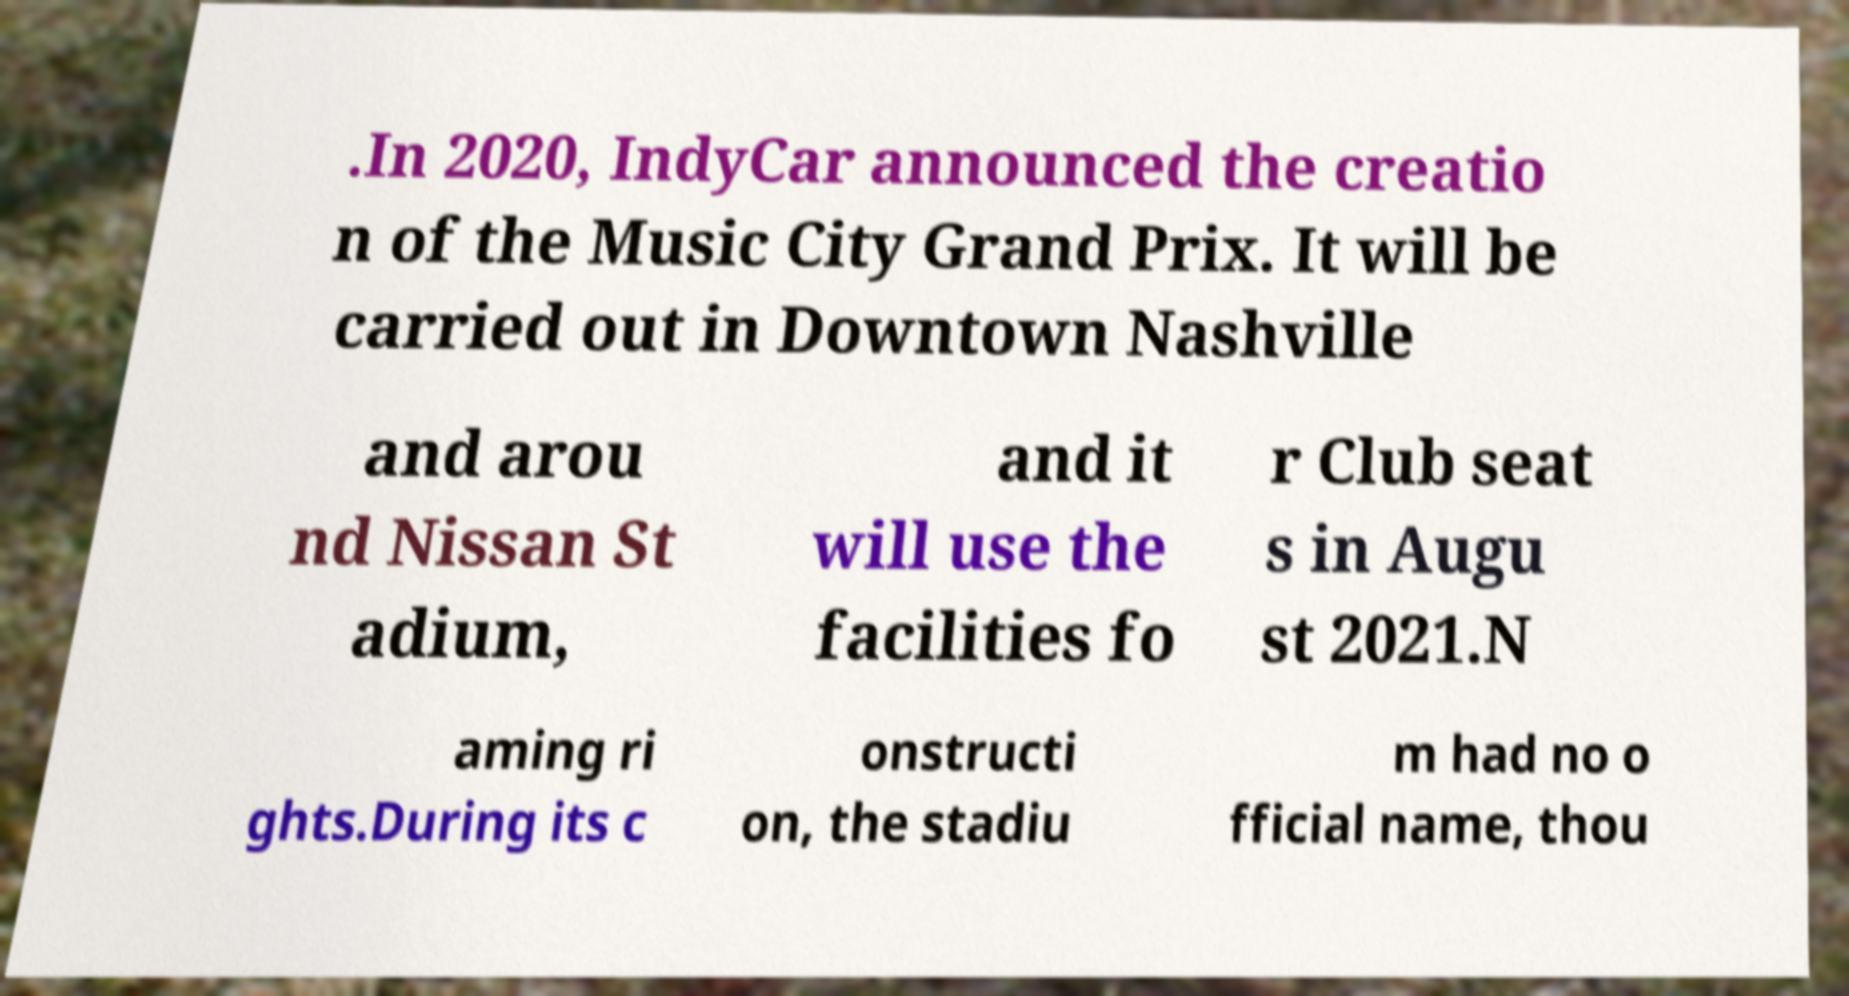For documentation purposes, I need the text within this image transcribed. Could you provide that? .In 2020, IndyCar announced the creatio n of the Music City Grand Prix. It will be carried out in Downtown Nashville and arou nd Nissan St adium, and it will use the facilities fo r Club seat s in Augu st 2021.N aming ri ghts.During its c onstructi on, the stadiu m had no o fficial name, thou 